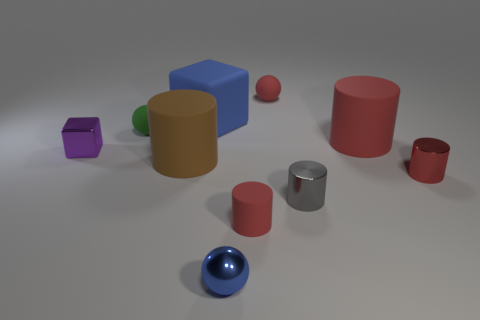What is the texture of the surface upon which the objects are placed? The surface appears to be smooth with a matte finish, possibly a synthetic material or coated metal, providing a neutral gray background for the objects. Does the arrangement of objects suggest anything about their purpose or the context of this image? The arrangement seems arbitrary, suggesting that the objects might be used for display or illustrative purposes, possibly for a color or shape study rather than any functional use. 